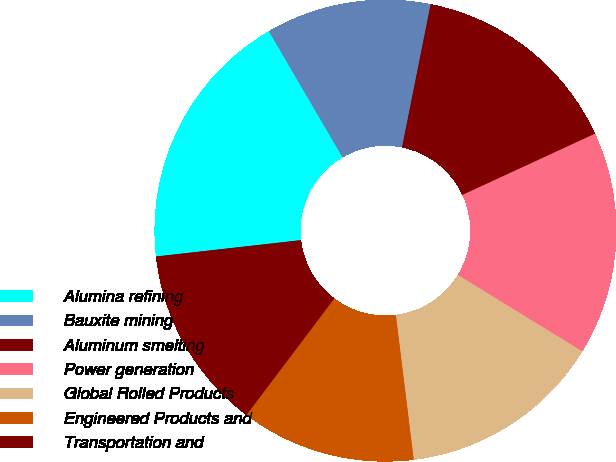Convert chart. <chart><loc_0><loc_0><loc_500><loc_500><pie_chart><fcel>Alumina refining<fcel>Bauxite mining<fcel>Aluminum smelting<fcel>Power generation<fcel>Global Rolled Products<fcel>Engineered Products and<fcel>Transportation and<nl><fcel>18.37%<fcel>11.56%<fcel>14.97%<fcel>15.65%<fcel>14.29%<fcel>12.24%<fcel>12.93%<nl></chart> 